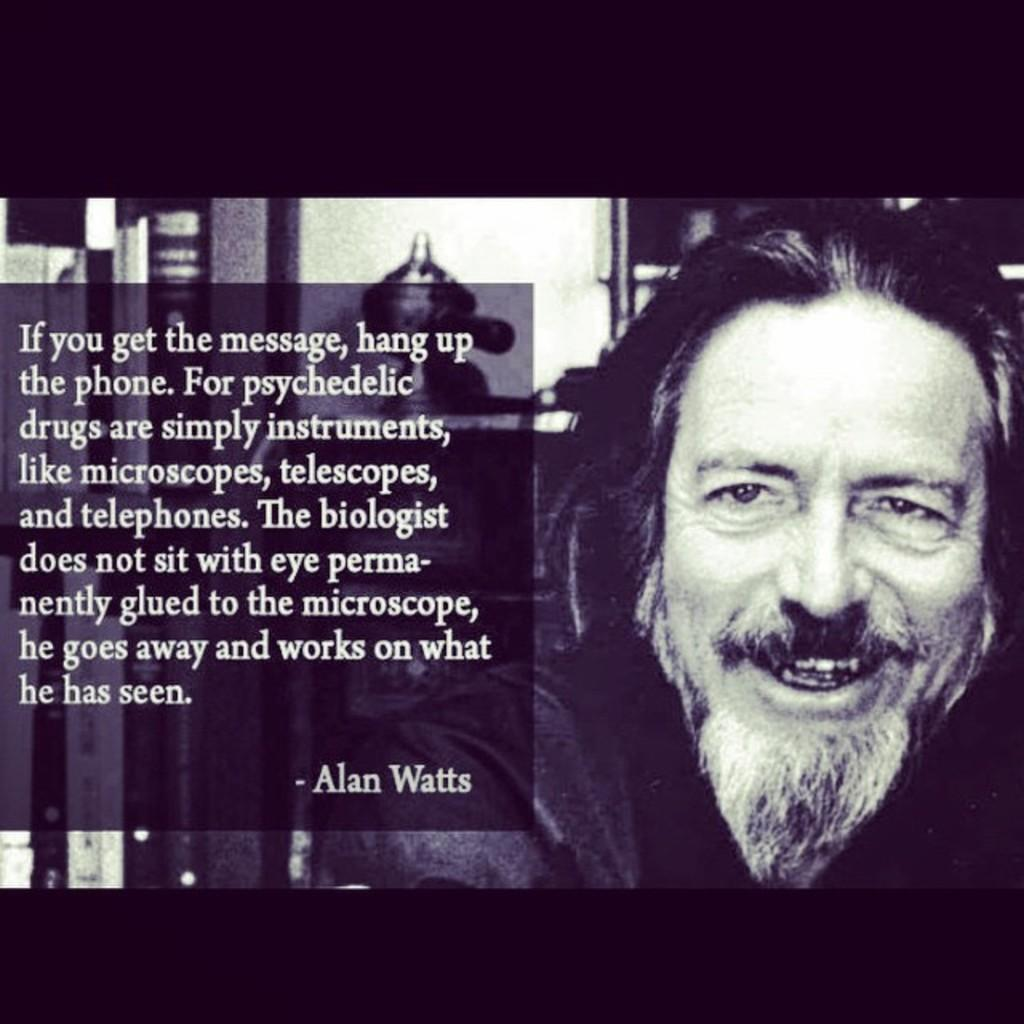Who or what is present in the image? There is a person in the image. What is the person doing or expressing? The person is smiling. What can be seen behind the person? There are objects behind the person. Is there any text or message on the image? Yes, there is a quotation on the image. Can you see any squirrels or ants interacting with the person in the image? No, there are no squirrels or ants present in the image. What type of land is visible in the background of the image? The provided facts do not mention any land or background, so it cannot be determined from the image. 